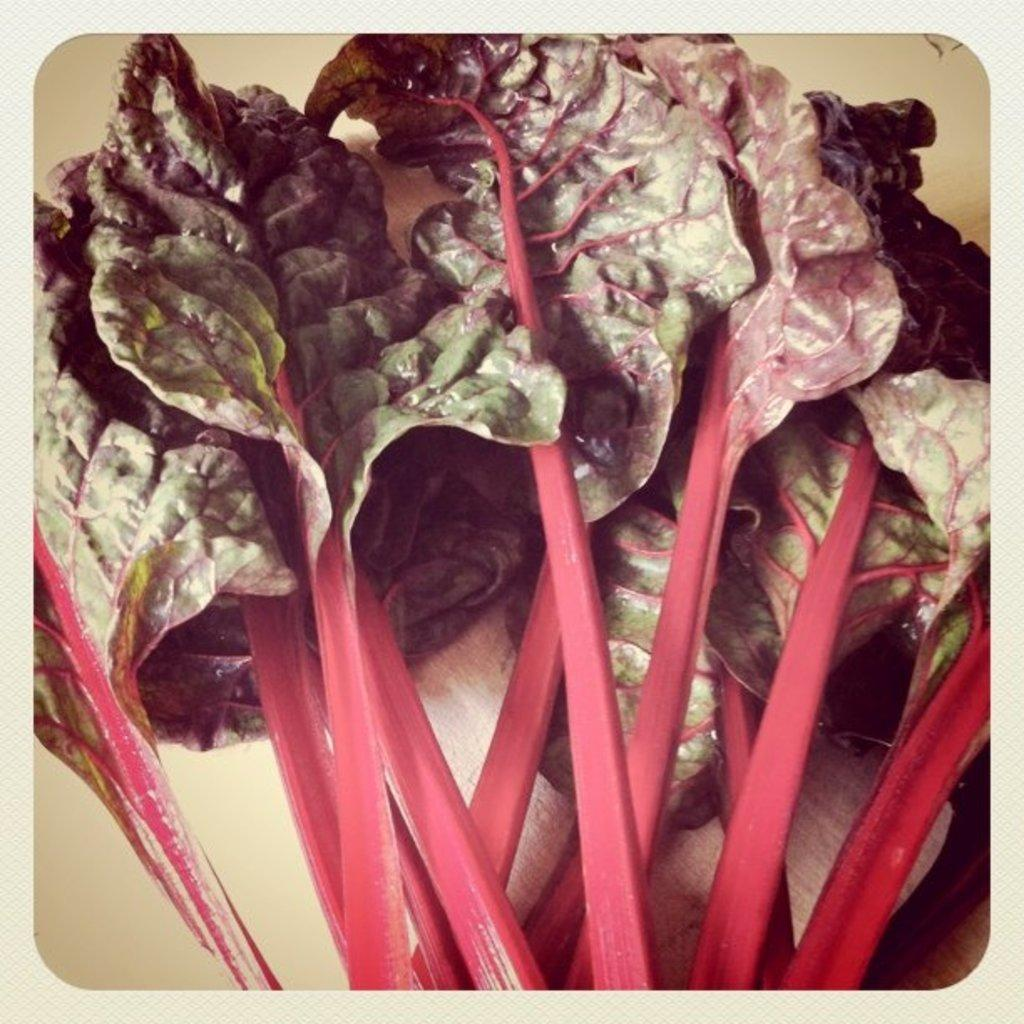What type of vegetables are in the image? There are leafy vegetables in the image. What color are the leafy vegetables? The leafy vegetables are green in color. Are there any other colors present on the leafy vegetables? Yes, the leafy vegetables have pink color elements. What type of spoon can be seen in the image? There is no spoon present in the image. Can you hear the leafy vegetables in the image? Leafy vegetables do not produce sound, so it is not possible to hear them in the image. 